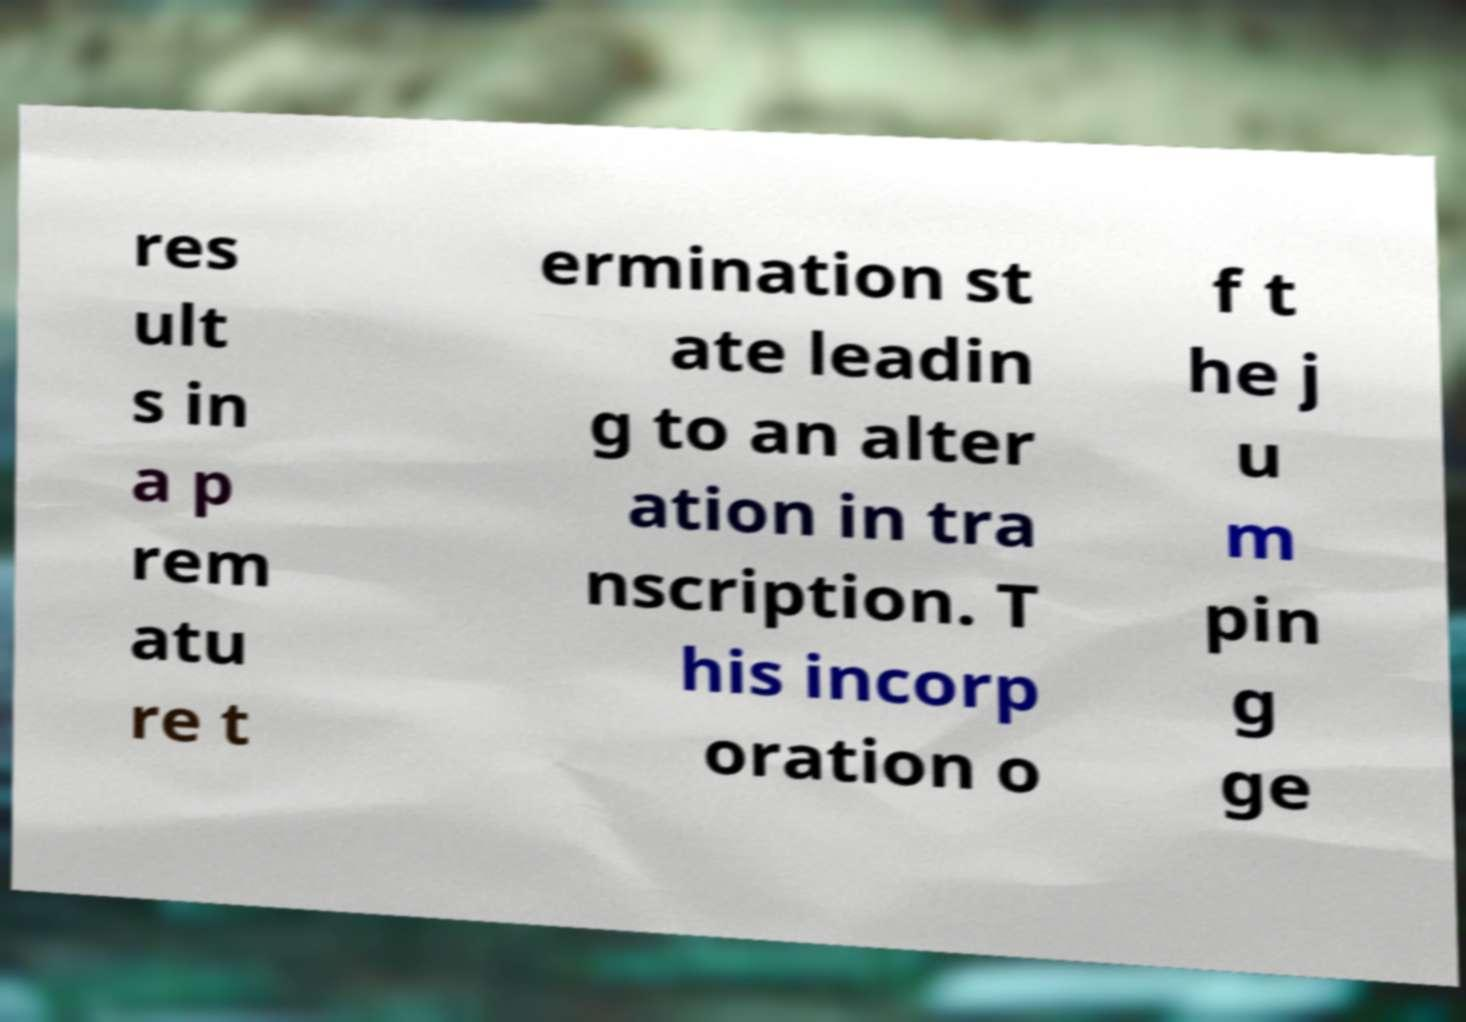What messages or text are displayed in this image? I need them in a readable, typed format. res ult s in a p rem atu re t ermination st ate leadin g to an alter ation in tra nscription. T his incorp oration o f t he j u m pin g ge 